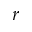<formula> <loc_0><loc_0><loc_500><loc_500>r</formula> 